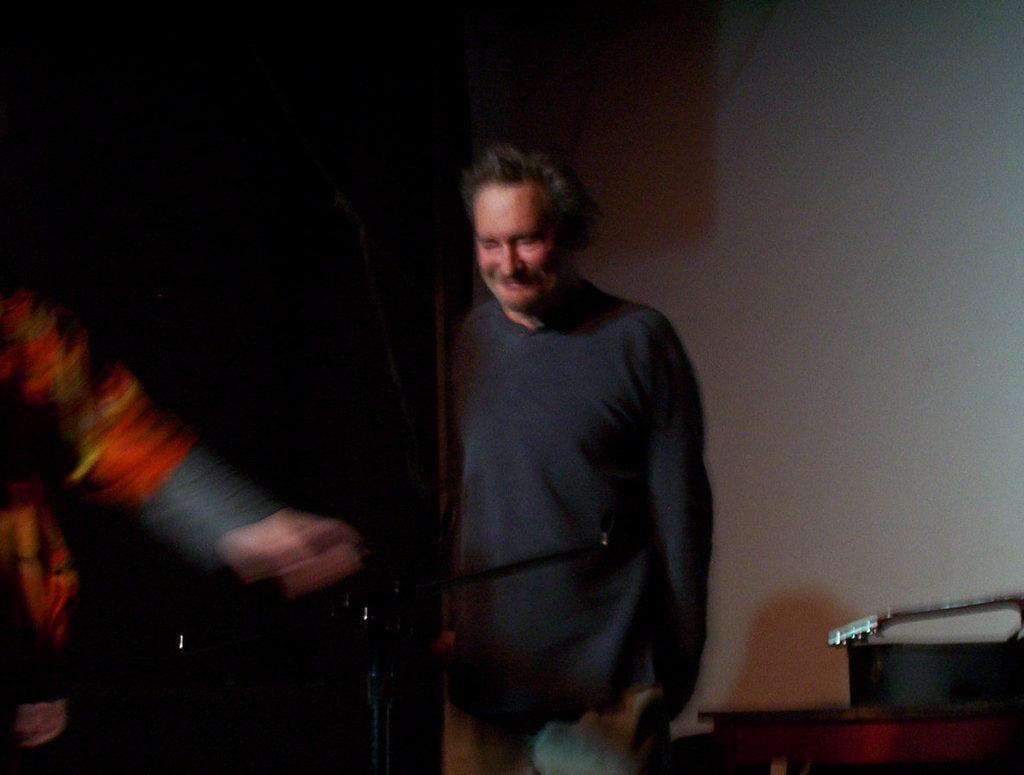Could you give a brief overview of what you see in this image? In this picture we can see a stand, two people and a man standing and smiling and at the back of him we can see the wall, some objects and in the background it is dark. 